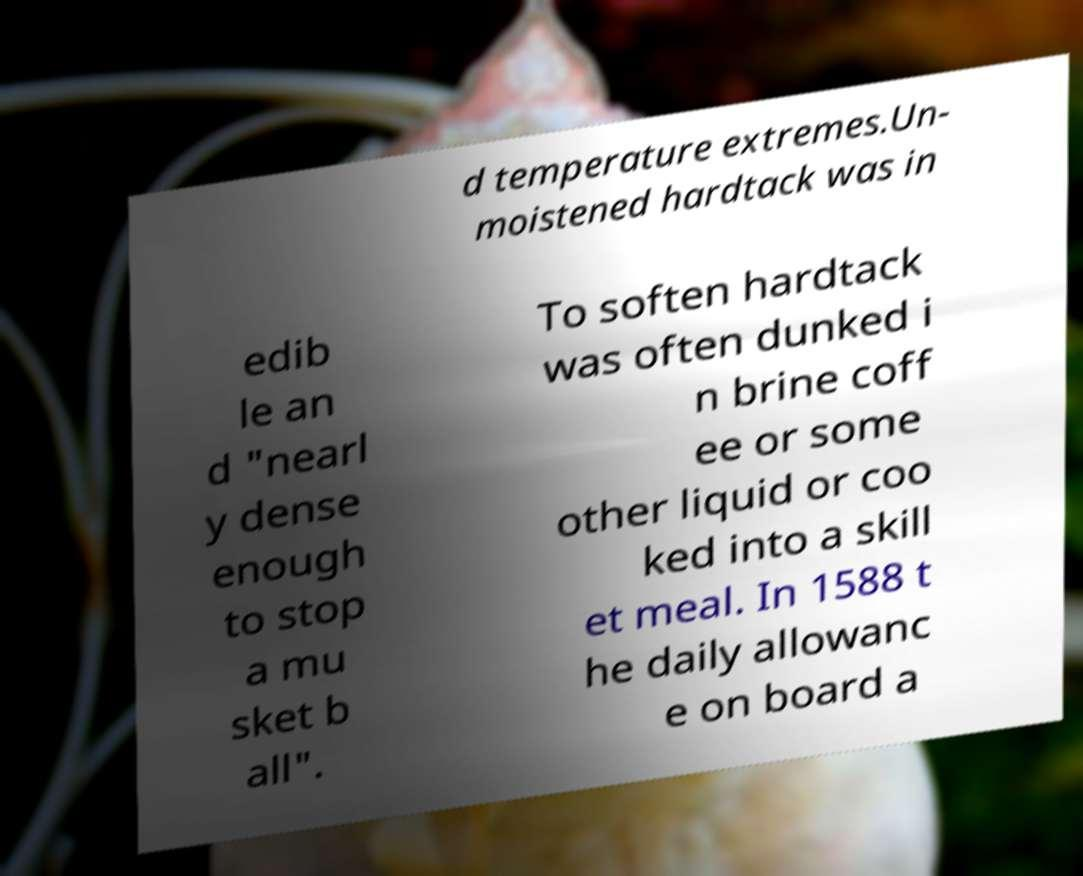For documentation purposes, I need the text within this image transcribed. Could you provide that? d temperature extremes.Un- moistened hardtack was in edib le an d "nearl y dense enough to stop a mu sket b all". To soften hardtack was often dunked i n brine coff ee or some other liquid or coo ked into a skill et meal. In 1588 t he daily allowanc e on board a 